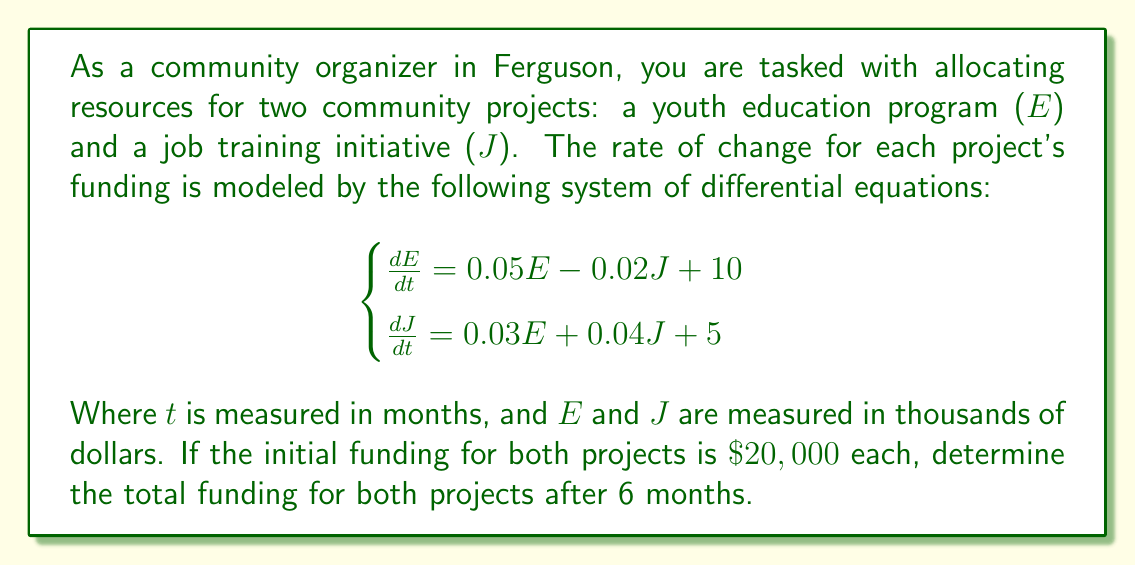Provide a solution to this math problem. To solve this system of differential equations, we'll use the matrix exponential method:

1) First, rewrite the system in matrix form:

   $$\frac{d}{dt}\begin{bmatrix} E \\ J \end{bmatrix} = \begin{bmatrix} 0.05 & -0.02 \\ 0.03 & 0.04 \end{bmatrix}\begin{bmatrix} E \\ J \end{bmatrix} + \begin{bmatrix} 10 \\ 5 \end{bmatrix}$$

2) Let $A = \begin{bmatrix} 0.05 & -0.02 \\ 0.03 & 0.04 \end{bmatrix}$ and $\vec{b} = \begin{bmatrix} 10 \\ 5 \end{bmatrix}$

3) The general solution is:

   $$\begin{bmatrix} E \\ J \end{bmatrix} = e^{At}\begin{bmatrix} E_0 \\ J_0 \end{bmatrix} + A^{-1}(e^{At} - I)\vec{b}$$

   where $E_0 = J_0 = 20$ (initial conditions)

4) Calculate $e^{At}$ using eigenvalues and eigenvectors:
   
   Eigenvalues: $\lambda_1 \approx 0.0941$, $\lambda_2 \approx -0.0041$
   
   Eigenvectors: $\vec{v_1} \approx \begin{bmatrix} 0.7071 \\ 0.7071 \end{bmatrix}$, $\vec{v_2} \approx \begin{bmatrix} -0.9239 \\ 0.3827 \end{bmatrix}$

   $$e^{At} = \begin{bmatrix} 0.7071 & -0.9239 \\ 0.7071 & 0.3827 \end{bmatrix}\begin{bmatrix} e^{0.0941t} & 0 \\ 0 & e^{-0.0041t} \end{bmatrix}\begin{bmatrix} 0.7071 & 0.7071 \\ -0.9239 & 0.3827 \end{bmatrix}$$

5) Calculate $A^{-1}$:

   $$A^{-1} = \begin{bmatrix} 22.2222 & 11.1111 \\ -16.6667 & 27.7778 \end{bmatrix}$$

6) Substitute $t = 6$ into the solution:

   $$\begin{bmatrix} E(6) \\ J(6) \end{bmatrix} = e^{6A}\begin{bmatrix} 20 \\ 20 \end{bmatrix} + A^{-1}(e^{6A} - I)\begin{bmatrix} 10 \\ 5 \end{bmatrix}$$

7) Evaluate numerically:

   $$\begin{bmatrix} E(6) \\ J(6) \end{bmatrix} \approx \begin{bmatrix} 115.8 \\ 92.4 \end{bmatrix}$$

8) Sum the components to get the total funding:

   $115.8 + 92.4 = 208.2$
Answer: The total funding for both projects after 6 months is approximately $\$208,200$. 